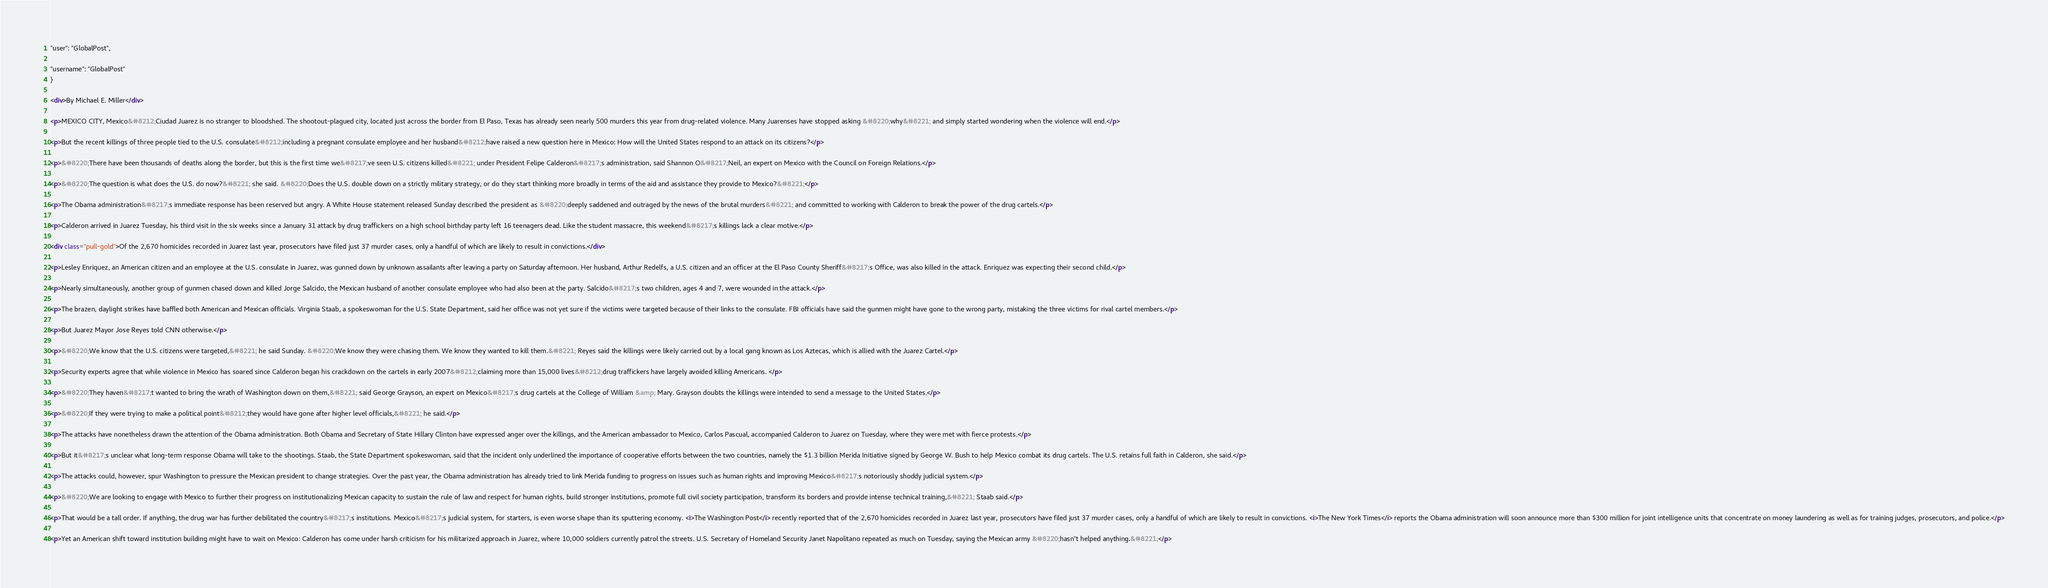<code> <loc_0><loc_0><loc_500><loc_500><_HTML_>











"user": "GlobalPost",

"username": "GlobalPost"
}

<div>By Michael E. Miller</div>

<p>MEXICO CITY, Mexico&#8212;Ciudad Juarez is no stranger to bloodshed. The shootout-plagued city, located just across the border from El Paso, Texas has already seen nearly 500 murders this year from drug-related violence. Many Juarenses have stopped asking &#8220;why&#8221; and simply started wondering when the violence will end.</p>

<p>But the recent killings of three people tied to the U.S. consulate&#8212;including a pregnant consulate employee and her husband&#8212;have raised a new question here in Mexico: How will the United States respond to an attack on its citizens?</p>

<p>&#8220;There have been thousands of deaths along the border, but this is the first time we&#8217;ve seen U.S. citizens killed&#8221; under President Felipe Calderon&#8217;s administration, said Shannon O&#8217;Neil, an expert on Mexico with the Council on Foreign Relations.</p>

<p>&#8220;The question is what does the U.S. do now?&#8221; she said. &#8220;Does the U.S. double down on a strictly military strategy, or do they start thinking more broadly in terms of the aid and assistance they provide to Mexico?&#8221;</p>

<p>The Obama administration&#8217;s immediate response has been reserved but angry. A White House statement released Sunday described the president as &#8220;deeply saddened and outraged by the news of the brutal murders&#8221; and committed to working with Calderon to break the power of the drug cartels.</p>

<p>Calderon arrived in Juarez Tuesday, his third visit in the six weeks since a January 31 attack by drug traffickers on a high school birthday party left 16 teenagers dead. Like the student massacre, this weekend&#8217;s killings lack a clear motive.</p>

<div class="pull-gold">Of the 2,670 homicides recorded in Juarez last year, prosecutors have filed just 37 murder cases, only a handful of which are likely to result in convictions.</div>

<p>Lesley Enriquez, an American citizen and an employee at the U.S. consulate in Juarez, was gunned down by unknown assailants after leaving a party on Saturday afternoon. Her husband, Arthur Redelfs, a U.S. citizen and an officer at the El Paso County Sheriff&#8217;s Office, was also killed in the attack. Enriquez was expecting their second child.</p>

<p>Nearly simultaneously, another group of gunmen chased down and killed Jorge Salcido, the Mexican husband of another consulate employee who had also been at the party. Salcido&#8217;s two children, ages 4 and 7, were wounded in the attack.</p>

<p>The brazen, daylight strikes have baffled both American and Mexican officials. Virginia Staab, a spokeswoman for the U.S. State Department, said her office was not yet sure if the victims were targeted because of their links to the consulate. FBI officials have said the gunmen might have gone to the wrong party, mistaking the three victims for rival cartel members.</p>

<p>But Juarez Mayor Jose Reyes told CNN otherwise.</p>

<p>&#8220;We know that the U.S. citizens were targeted,&#8221; he said Sunday. &#8220;We know they were chasing them. We know they wanted to kill them.&#8221; Reyes said the killings were likely carried out by a local gang known as Los Aztecas, which is allied with the Juarez Cartel.</p>

<p>Security experts agree that while violence in Mexico has soared since Calderon began his crackdown on the cartels in early 2007&#8212;claiming more than 15,000 lives&#8212;drug traffickers have largely avoided killing Americans. </p>

<p>&#8220;They haven&#8217;t wanted to bring the wrath of Washington down on them,&#8221; said George Grayson, an expert on Mexico&#8217;s drug cartels at the College of William &amp; Mary. Grayson doubts the killings were intended to send a message to the United States.</p>

<p>&#8220;If they were trying to make a political point&#8212;they would have gone after higher level officials,&#8221; he said.</p>

<p>The attacks have nonetheless drawn the attention of the Obama administration. Both Obama and Secretary of State Hillary Clinton have expressed anger over the killings, and the American ambassador to Mexico, Carlos Pascual, accompanied Calderon to Juarez on Tuesday, where they were met with fierce protests.</p>

<p>But it&#8217;s unclear what long-term response Obama will take to the shootings. Staab, the State Department spokeswoman, said that the incident only underlined the importance of cooperative efforts between the two countries, namely the $1.3 billion Merida Initiative signed by George W. Bush to help Mexico combat its drug cartels. The U.S. retains full faith in Calderon, she said.</p>

<p>The attacks could, however, spur Washington to pressure the Mexican president to change strategies. Over the past year, the Obama administration has already tried to link Merida funding to progress on issues such as human rights and improving Mexico&#8217;s notoriously shoddy judicial system.</p>

<p>&#8220;We are looking to engage with Mexico to further their progress on institutionalizing Mexican capacity to sustain the rule of law and respect for human rights, build stronger institutions, promote full civil society participation, transform its borders and provide intense technical training,&#8221; Staab said.</p>

<p>That would be a tall order. If anything, the drug war has further debilitated the country&#8217;s institutions. Mexico&#8217;s judicial system, for starters, is even worse shape than its sputtering economy. <i>The Washington Post</i> recently reported that of the 2,670 homicides recorded in Juarez last year, prosecutors have filed just 37 murder cases, only a handful of which are likely to result in convictions. <i>The New York Times</i> reports the Obama administration will soon announce more than $300 million for joint intelligence units that concentrate on money laundering as well as for training judges, prosecutors, and police.</p>

<p>Yet an American shift toward institution building might have to wait on Mexico: Calderon has come under harsh criticism for his militarized approach in Juarez, where 10,000 soldiers currently patrol the streets. U.S. Secretary of Homeland Security Janet Napolitano repeated as much on Tuesday, saying the Mexican army &#8220;hasn"t helped anything.&#8221;</p>
</code> 